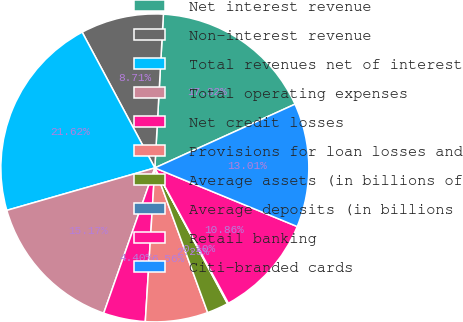Convert chart. <chart><loc_0><loc_0><loc_500><loc_500><pie_chart><fcel>Net interest revenue<fcel>Non-interest revenue<fcel>Total revenues net of interest<fcel>Total operating expenses<fcel>Net credit losses<fcel>Provisions for loan losses and<fcel>Average assets (in billions of<fcel>Average deposits (in billions<fcel>Retail banking<fcel>Citi-branded cards<nl><fcel>17.32%<fcel>8.71%<fcel>21.62%<fcel>15.17%<fcel>4.4%<fcel>6.56%<fcel>2.25%<fcel>0.1%<fcel>10.86%<fcel>13.01%<nl></chart> 